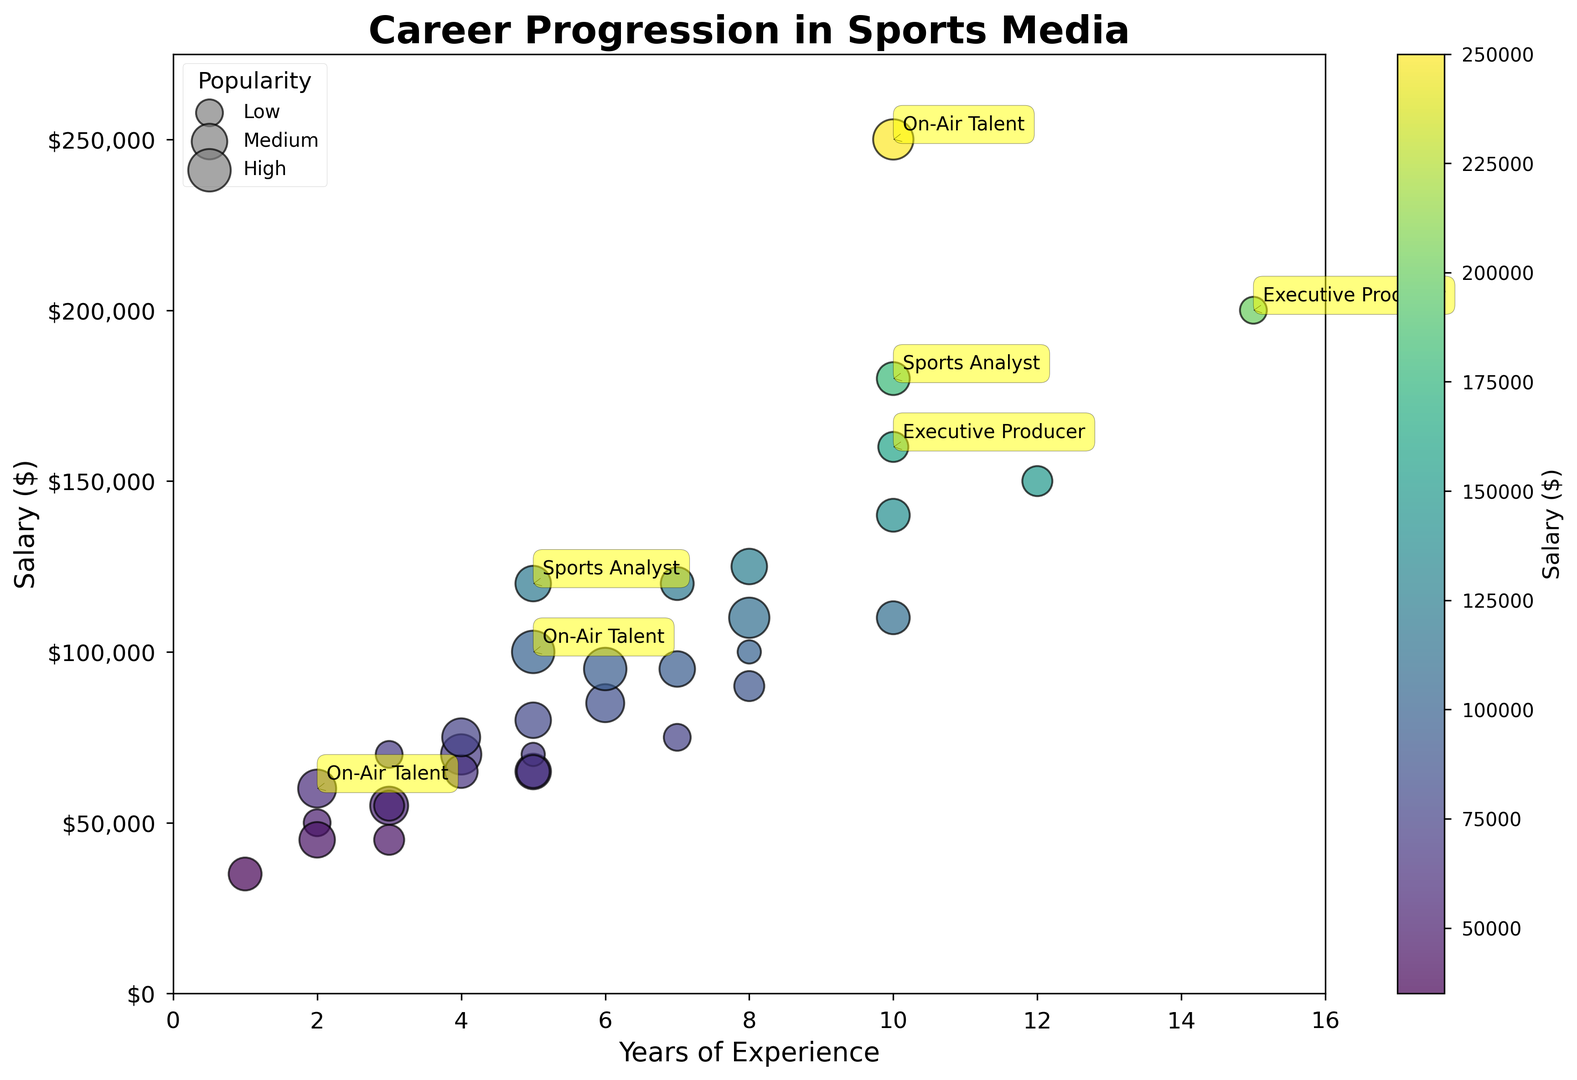What position has the highest salary in the figure? By looking at the topmost bubble on the chart, we see that the highest salary bubble is for the On-Air Talent with a salary value of $250,000.
Answer: On-Air Talent Which position has the lowest popularity with a mid-range salary? To determine this, look at medium-sized bubbles that are not visually prominent (smaller size). The mid-range salary is around $70,000; the Graphics Operator with a $70,000 salary has a relatively small bubble indicating lower popularity (15).
Answer: Graphics Operator How does the popularity of the Senior Producer compare to the Graphic Operator in terms of bubble size? The bubble size for popularity directly correlates to its popularity value. The Senior Producer has 30 in popularity, while the Graphics Operator has 20. Therefore, the Senior Producer's bubble is larger.
Answer: Larger What is the average salary for positions with 5 years of experience? We identify positions with 5 years of experience: Production Coordinator, Technical Director, Digital Content Producer, Social Media Coordinator, and Sports Analyst with salaries of $65,000, $80,000, $95,000, $65,000, and $120,000 respectively. Average = (65,000+80,000+95,000+65,000+120,000) / 5 = $85,000.
Answer: $85,000 Which role with the same years of experience has a higher salary, Production Assistant with 3 years of experience or Camera Operator with 3 years of experience? Compare the salaries for both roles with 3 years of experience. Production Assistant has a salary of $45,000 and the Camera Operator has a salary of $55,000. The Camera Operator thus has a higher salary.
Answer: Camera Operator What is the trend in salary with increasing years of experience for the On-Air Talent position? Observing bubbles marked for On-Air Talent, their positions reflect increasing salaries ($60,000, $100,000, $250,000) corresponding to 2, 5, and 10 years of experience respectively, indicating a clear upward trend.
Answer: Upward trend What's the difference in salary between a Producer at 6 years and a Digital Content Producer at the same experience level? The Producer at 6 years has a salary of $95,000 and the Digital Content Producer has $75,000. The difference is $95,000 - $75,000 = $20,000.
Answer: $20,000 Which roles have a salary between $100,000 and $150,000 with different colored bubbles indicating variation in salary? Look for roles within this salary range shown by differently colored bubbles: Producer (8 years), Director (7 years), On-Air Talent (5 years), and Technical Director (10 years).
Answer: Producer, Director, On-Air Talent, Technical Director What is the salary range for positions with at least 10 years of experience? We observe the salary for positions with 10 or more years: Senior Producer ($140,000), Executive Producer ($160,000, $200,000), Sports Analyst ($180,000), Director ($150,000), Technical Director ($110,000), On-Air Talent ($250,000). The range is $110,000 to $250,000.
Answer: $110,000 - $250,000 